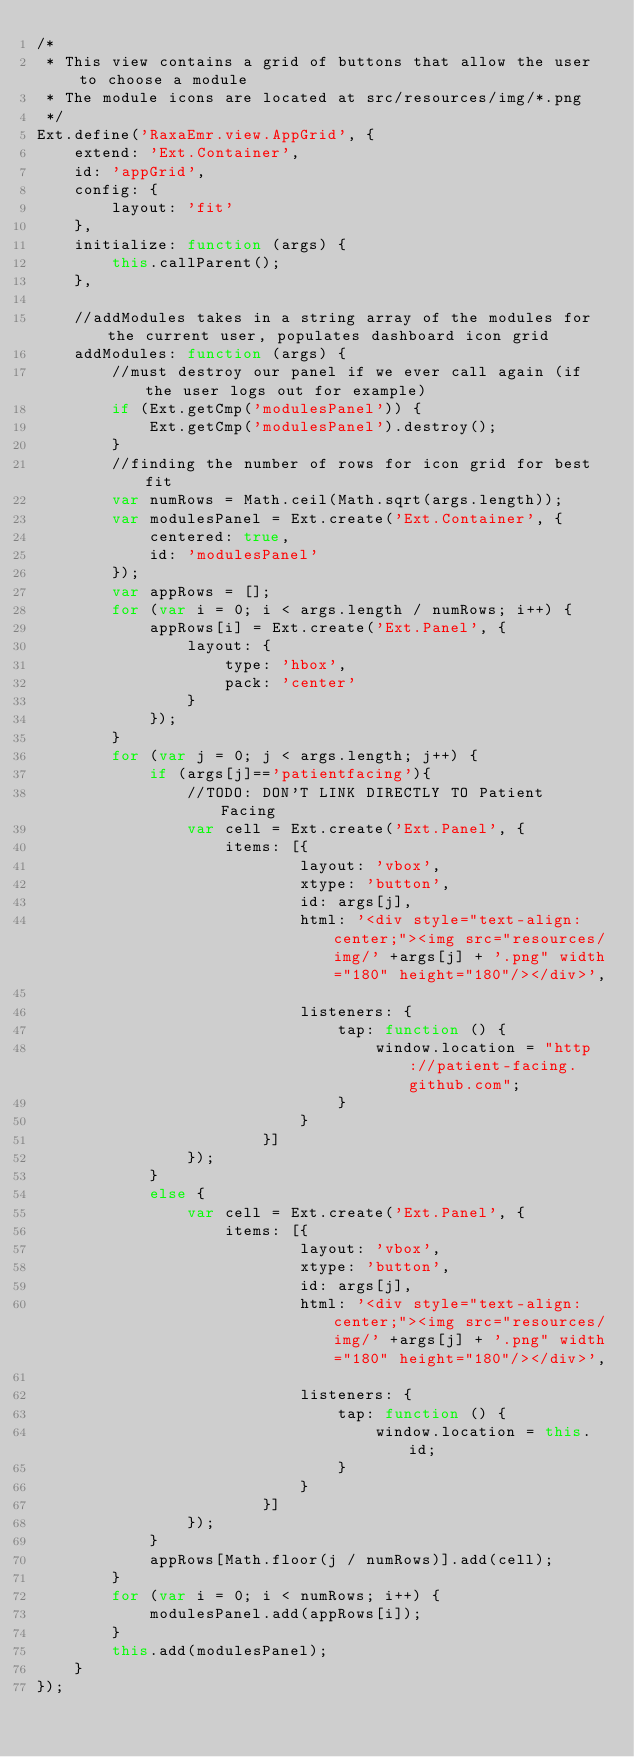<code> <loc_0><loc_0><loc_500><loc_500><_JavaScript_>/*
 * This view contains a grid of buttons that allow the user to choose a module
 * The module icons are located at src/resources/img/*.png
 */
Ext.define('RaxaEmr.view.AppGrid', {
    extend: 'Ext.Container',
    id: 'appGrid',
    config: {
        layout: 'fit'
    },
    initialize: function (args) {
        this.callParent();
    },
    
    //addModules takes in a string array of the modules for the current user, populates dashboard icon grid
    addModules: function (args) {
        //must destroy our panel if we ever call again (if the user logs out for example)
        if (Ext.getCmp('modulesPanel')) {
            Ext.getCmp('modulesPanel').destroy();
        }
        //finding the number of rows for icon grid for best fit
        var numRows = Math.ceil(Math.sqrt(args.length));
        var modulesPanel = Ext.create('Ext.Container', {
            centered: true,
            id: 'modulesPanel'
        });
        var appRows = [];
        for (var i = 0; i < args.length / numRows; i++) {
            appRows[i] = Ext.create('Ext.Panel', {
                layout: {
                    type: 'hbox',
                    pack: 'center'
                }
            });
        }
        for (var j = 0; j < args.length; j++) {
            if (args[j]=='patientfacing'){
                //TODO: DON'T LINK DIRECTLY TO Patient Facing
                var cell = Ext.create('Ext.Panel', {
                    items: [{
                            layout: 'vbox',
                            xtype: 'button',
                            id: args[j],
                            html: '<div style="text-align:center;"><img src="resources/img/' +args[j] + '.png" width="180" height="180"/></div>',

                            listeners: {
                                tap: function () {
                                    window.location = "http://patient-facing.github.com";
                                }
                            }
                        }]
                });
            }
            else {
                var cell = Ext.create('Ext.Panel', {
                    items: [{
                            layout: 'vbox',
                            xtype: 'button',
                            id: args[j],
                            html: '<div style="text-align:center;"><img src="resources/img/' +args[j] + '.png" width="180" height="180"/></div>',

                            listeners: {
                                tap: function () {
                                    window.location = this.id;
                                }
                            }
                        }]
                });
            }
            appRows[Math.floor(j / numRows)].add(cell);
        }     
        for (var i = 0; i < numRows; i++) {
            modulesPanel.add(appRows[i]);
        }
        this.add(modulesPanel);
    }
});</code> 